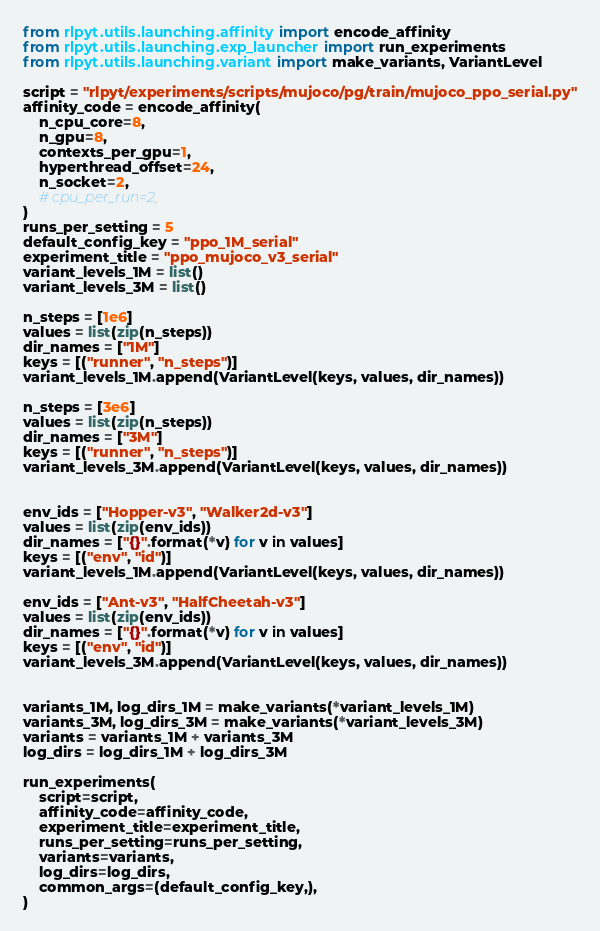Convert code to text. <code><loc_0><loc_0><loc_500><loc_500><_Python_>
from rlpyt.utils.launching.affinity import encode_affinity
from rlpyt.utils.launching.exp_launcher import run_experiments
from rlpyt.utils.launching.variant import make_variants, VariantLevel

script = "rlpyt/experiments/scripts/mujoco/pg/train/mujoco_ppo_serial.py"
affinity_code = encode_affinity(
    n_cpu_core=8,
    n_gpu=8,
    contexts_per_gpu=1,
    hyperthread_offset=24,
    n_socket=2,
    # cpu_per_run=2,
)
runs_per_setting = 5
default_config_key = "ppo_1M_serial"
experiment_title = "ppo_mujoco_v3_serial"
variant_levels_1M = list()
variant_levels_3M = list()

n_steps = [1e6]
values = list(zip(n_steps))
dir_names = ["1M"]
keys = [("runner", "n_steps")]
variant_levels_1M.append(VariantLevel(keys, values, dir_names))

n_steps = [3e6]
values = list(zip(n_steps))
dir_names = ["3M"]
keys = [("runner", "n_steps")]
variant_levels_3M.append(VariantLevel(keys, values, dir_names))


env_ids = ["Hopper-v3", "Walker2d-v3"]
values = list(zip(env_ids))
dir_names = ["{}".format(*v) for v in values]
keys = [("env", "id")]
variant_levels_1M.append(VariantLevel(keys, values, dir_names))

env_ids = ["Ant-v3", "HalfCheetah-v3"]
values = list(zip(env_ids))
dir_names = ["{}".format(*v) for v in values]
keys = [("env", "id")]
variant_levels_3M.append(VariantLevel(keys, values, dir_names))


variants_1M, log_dirs_1M = make_variants(*variant_levels_1M)
variants_3M, log_dirs_3M = make_variants(*variant_levels_3M)
variants = variants_1M + variants_3M
log_dirs = log_dirs_1M + log_dirs_3M

run_experiments(
    script=script,
    affinity_code=affinity_code,
    experiment_title=experiment_title,
    runs_per_setting=runs_per_setting,
    variants=variants,
    log_dirs=log_dirs,
    common_args=(default_config_key,),
)

</code> 